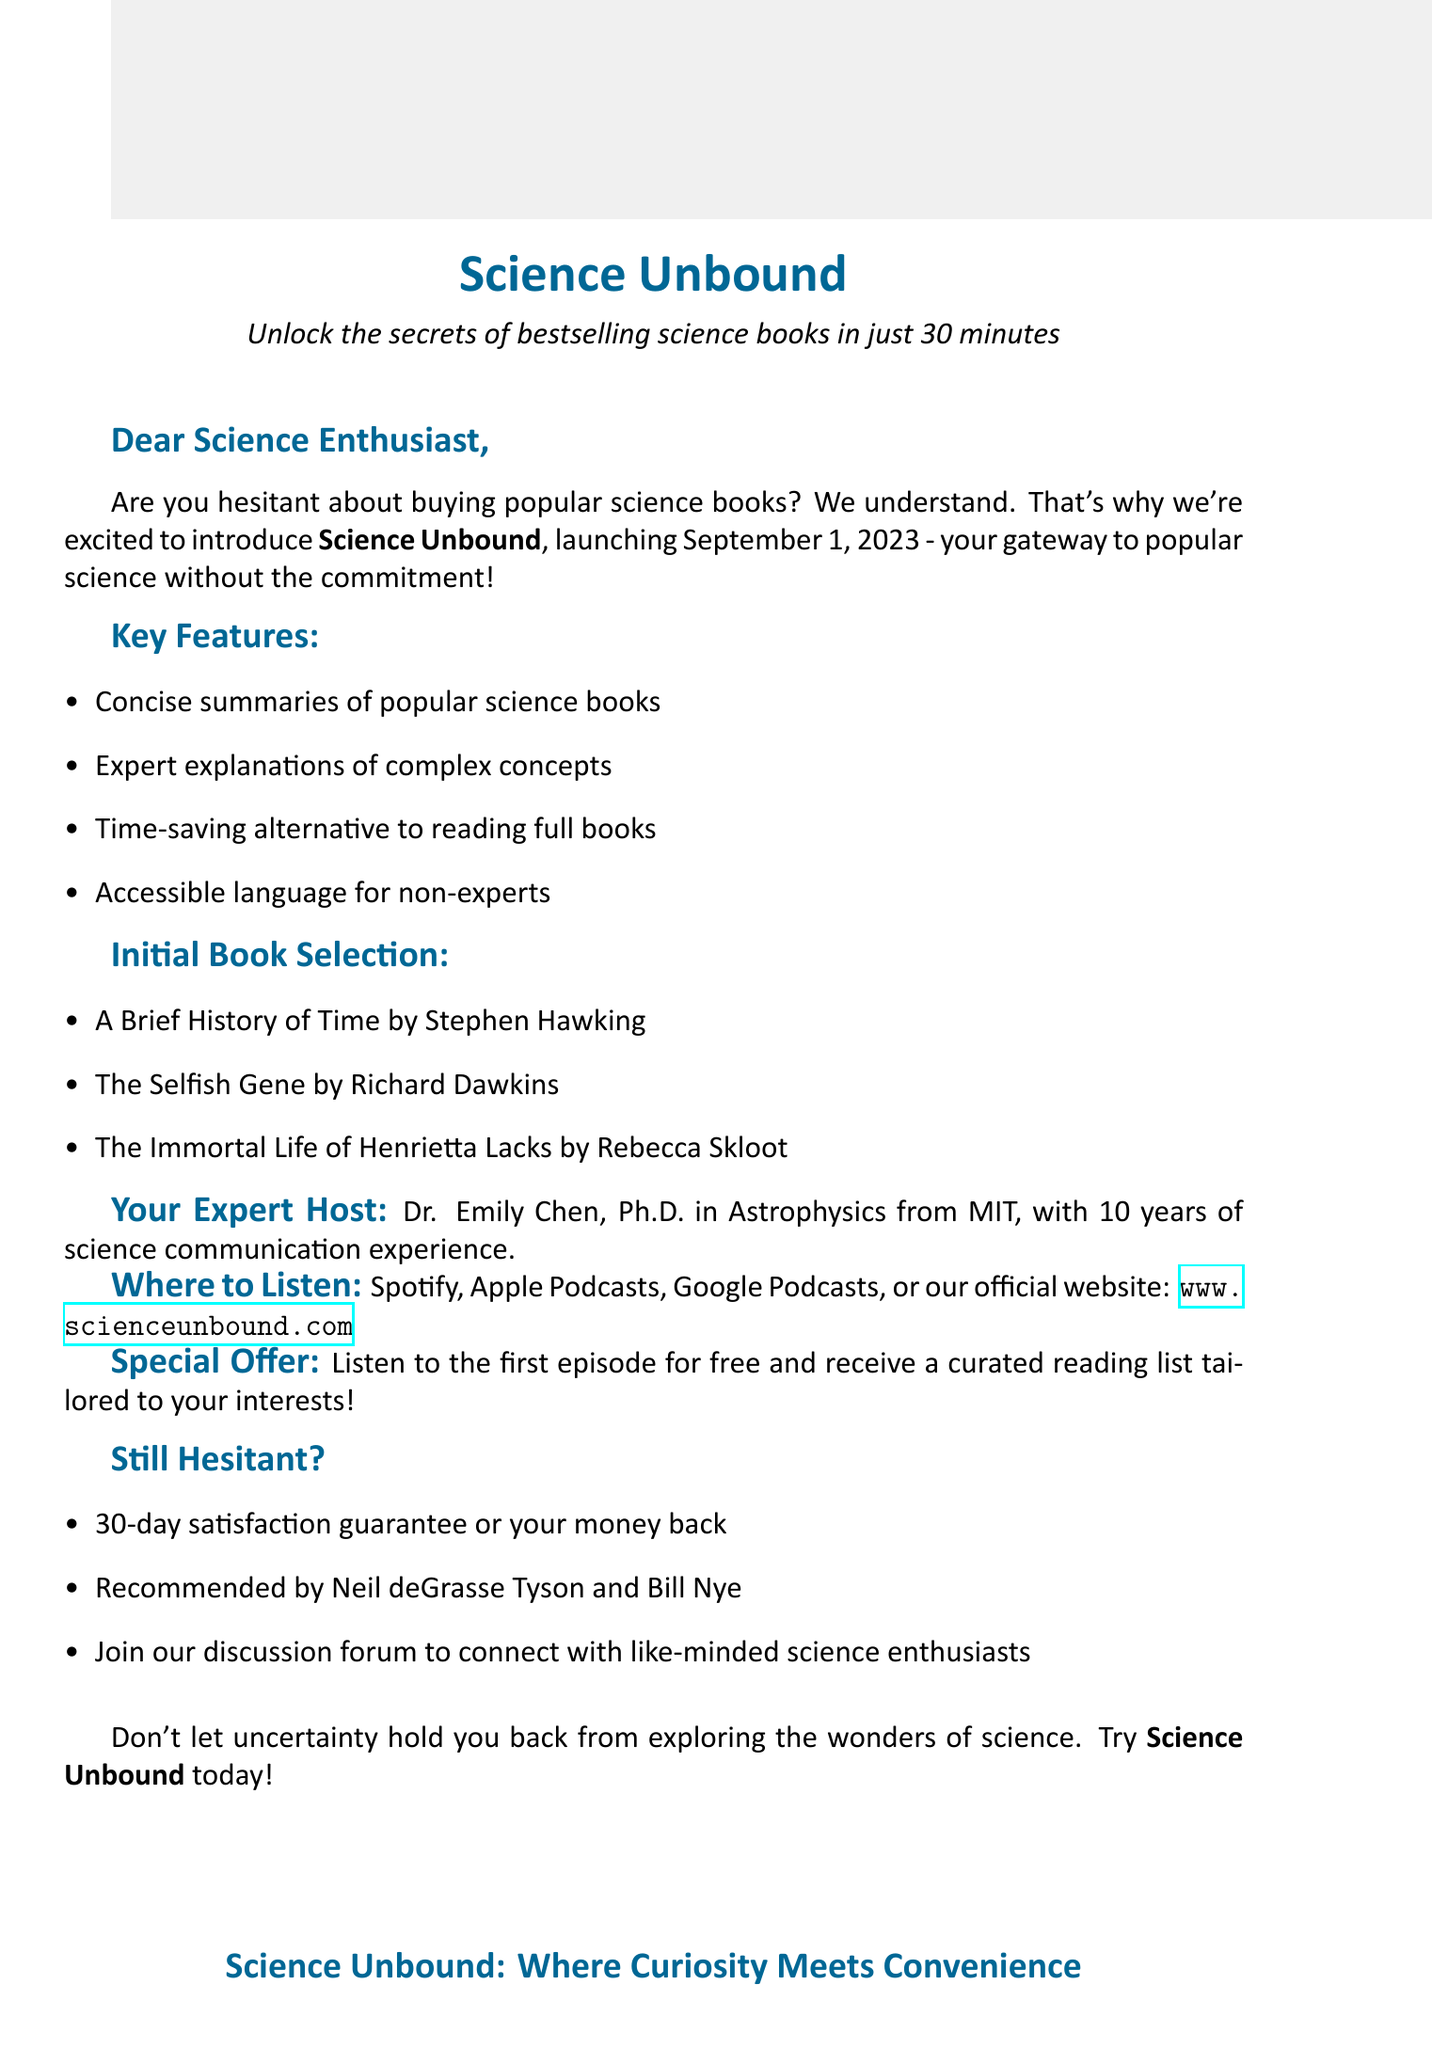What is the name of the podcast? The name of the podcast is mentioned in the introduction as "Science Unbound".
Answer: Science Unbound When was the podcast launched? The launch date of the podcast is provided in the introduction as September 1, 2023.
Answer: September 1, 2023 Who is the host of the podcast? The document specifies the host's name and credentials in the host information section, which is Dr. Emily Chen.
Answer: Dr. Emily Chen What is a key feature of the podcast? Several key features are listed, and one of them is "Concise summaries of popular science books".
Answer: Concise summaries of popular science books Which platform is NOT mentioned for listening? The document lists various platforms to listen to the podcast, and one that is not listed is "YouTube".
Answer: YouTube What is the satisfaction guarantee period? The document states that there is a 30-day satisfaction guarantee, indicating the timeframe for the guarantee.
Answer: 30-day Who recommended the podcast? The document mentions two prominent figures who have recommended the podcast: Neil deGrasse Tyson and Bill Nye.
Answer: Neil deGrasse Tyson and Bill Nye What special offer is provided for new listeners? The special offer in the document states listeners can "Listen to the first episode for free".
Answer: Listen to the first episode for free What kind of reading list will be offered? The document describes that listeners will receive "a curated reading list of science books tailored to your interests".
Answer: curated reading list of science books tailored to your interests 